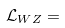<formula> <loc_0><loc_0><loc_500><loc_500>\mathcal { L } _ { W Z } =</formula> 